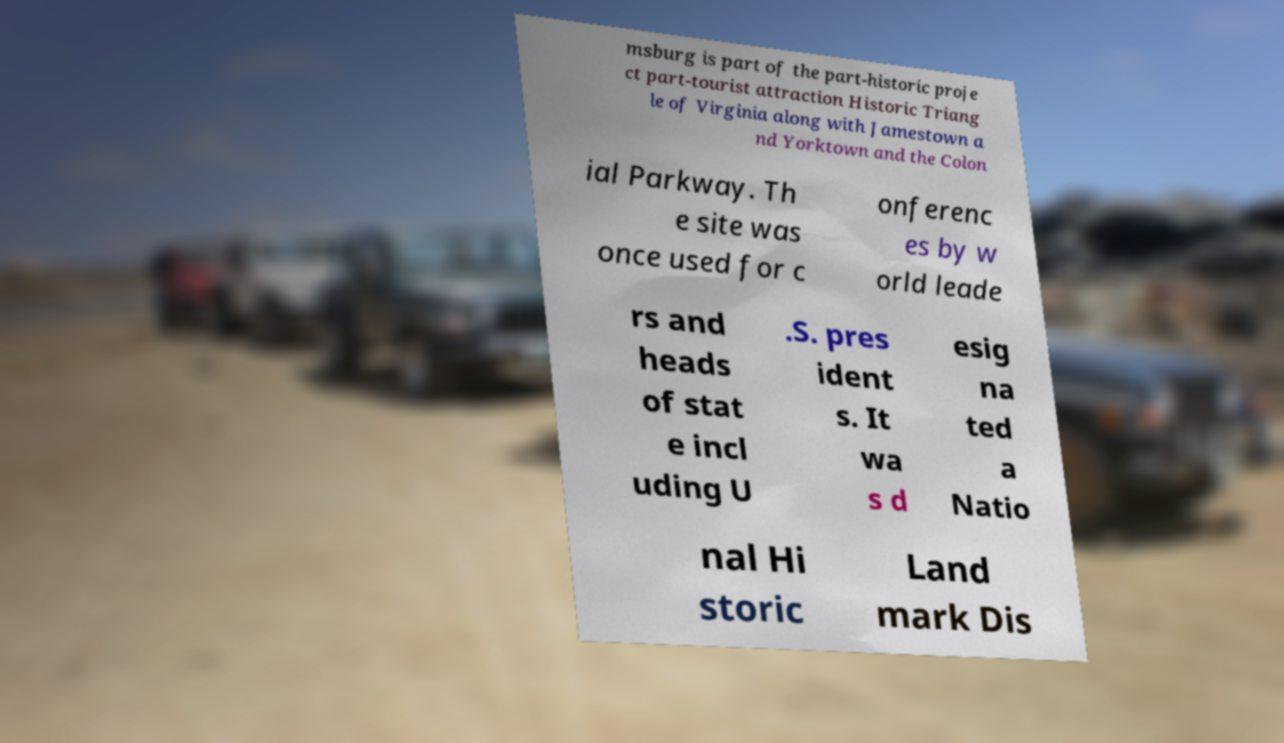There's text embedded in this image that I need extracted. Can you transcribe it verbatim? msburg is part of the part-historic proje ct part-tourist attraction Historic Triang le of Virginia along with Jamestown a nd Yorktown and the Colon ial Parkway. Th e site was once used for c onferenc es by w orld leade rs and heads of stat e incl uding U .S. pres ident s. It wa s d esig na ted a Natio nal Hi storic Land mark Dis 